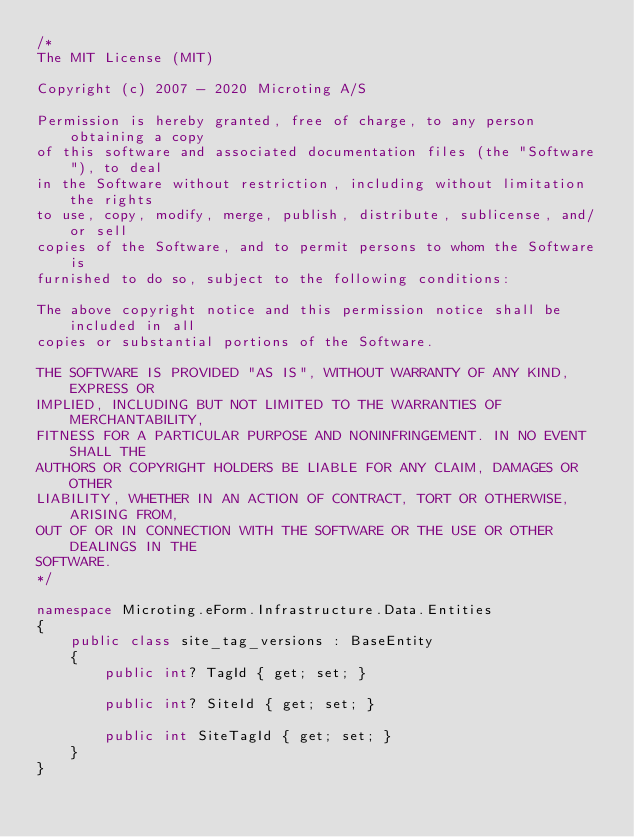Convert code to text. <code><loc_0><loc_0><loc_500><loc_500><_C#_>/*
The MIT License (MIT)

Copyright (c) 2007 - 2020 Microting A/S

Permission is hereby granted, free of charge, to any person obtaining a copy
of this software and associated documentation files (the "Software"), to deal
in the Software without restriction, including without limitation the rights
to use, copy, modify, merge, publish, distribute, sublicense, and/or sell
copies of the Software, and to permit persons to whom the Software is
furnished to do so, subject to the following conditions:

The above copyright notice and this permission notice shall be included in all
copies or substantial portions of the Software.

THE SOFTWARE IS PROVIDED "AS IS", WITHOUT WARRANTY OF ANY KIND, EXPRESS OR
IMPLIED, INCLUDING BUT NOT LIMITED TO THE WARRANTIES OF MERCHANTABILITY,
FITNESS FOR A PARTICULAR PURPOSE AND NONINFRINGEMENT. IN NO EVENT SHALL THE
AUTHORS OR COPYRIGHT HOLDERS BE LIABLE FOR ANY CLAIM, DAMAGES OR OTHER
LIABILITY, WHETHER IN AN ACTION OF CONTRACT, TORT OR OTHERWISE, ARISING FROM,
OUT OF OR IN CONNECTION WITH THE SOFTWARE OR THE USE OR OTHER DEALINGS IN THE
SOFTWARE.
*/

namespace Microting.eForm.Infrastructure.Data.Entities
{
    public class site_tag_versions : BaseEntity
    {
        public int? TagId { get; set; }
        
        public int? SiteId { get; set; }
        
        public int SiteTagId { get; set; }
    }
}</code> 